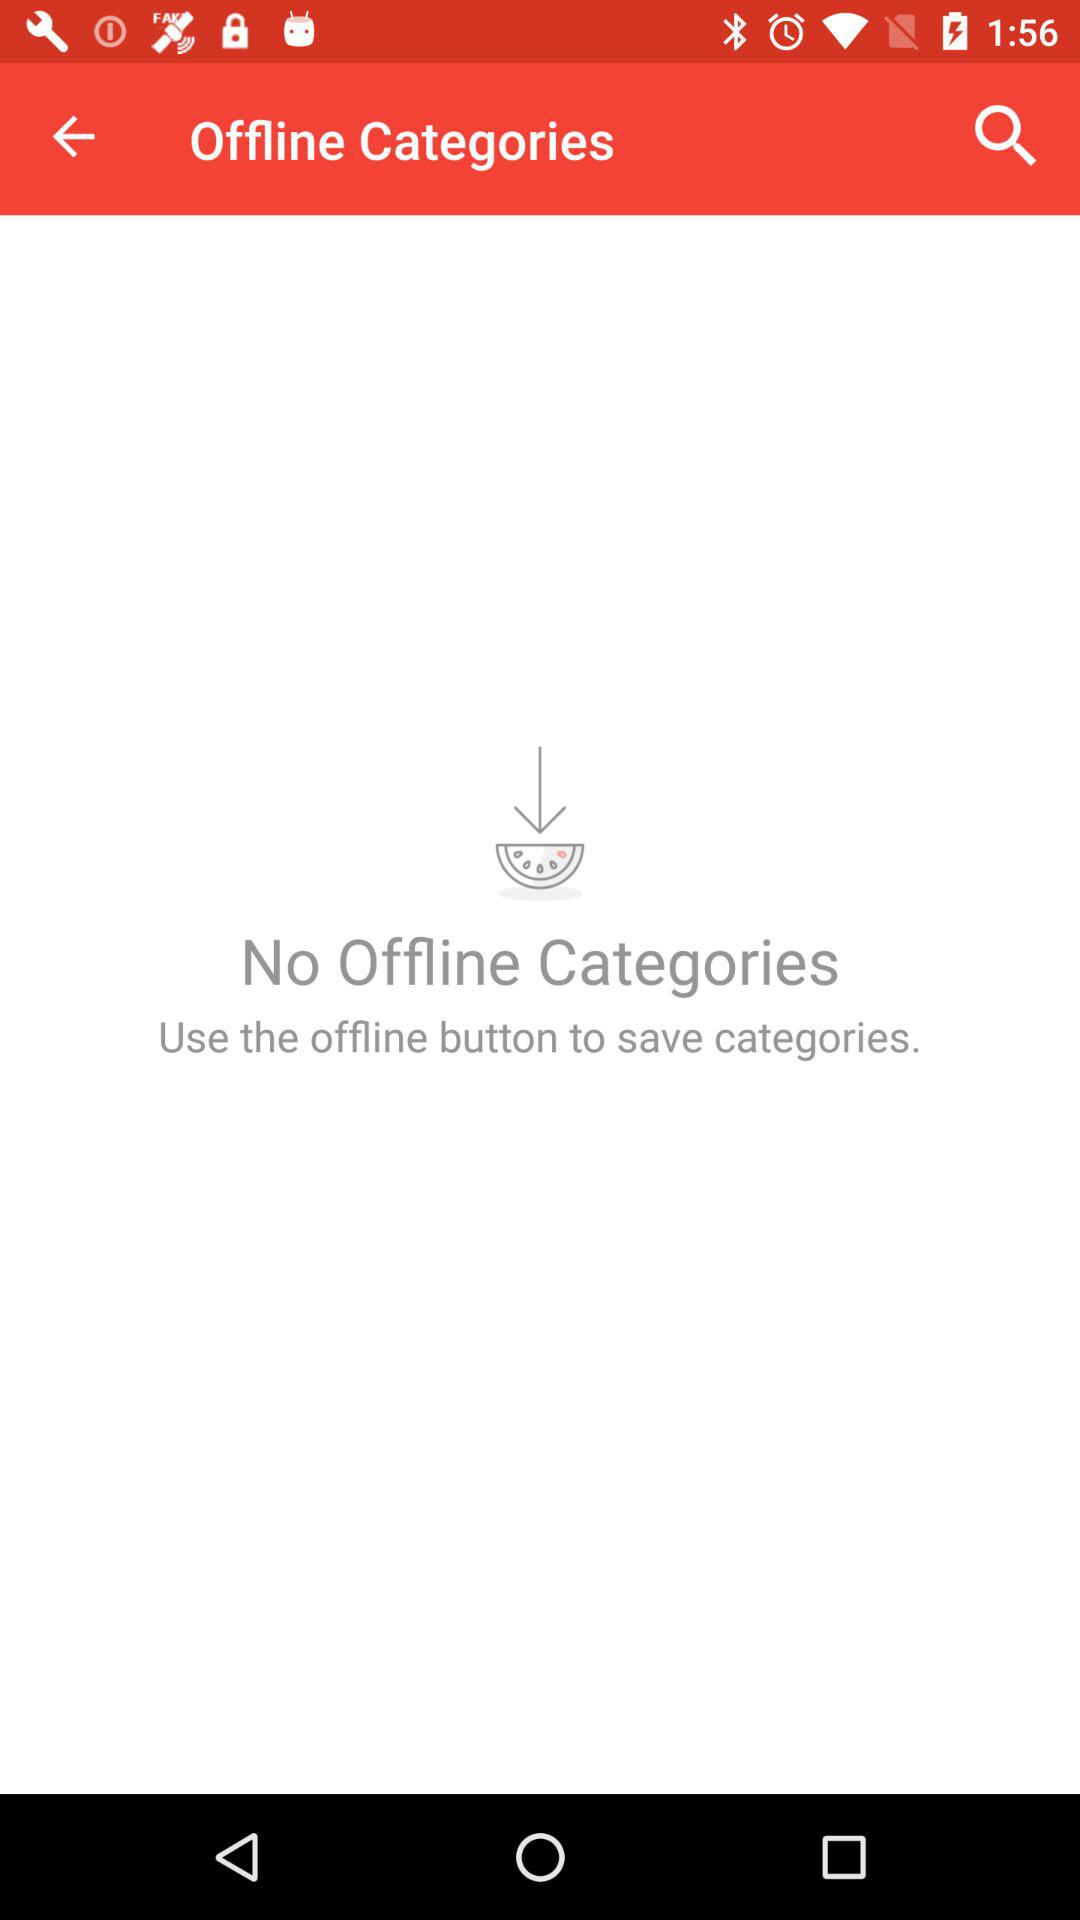Which categories are saved?
When the provided information is insufficient, respond with <no answer>. <no answer> 